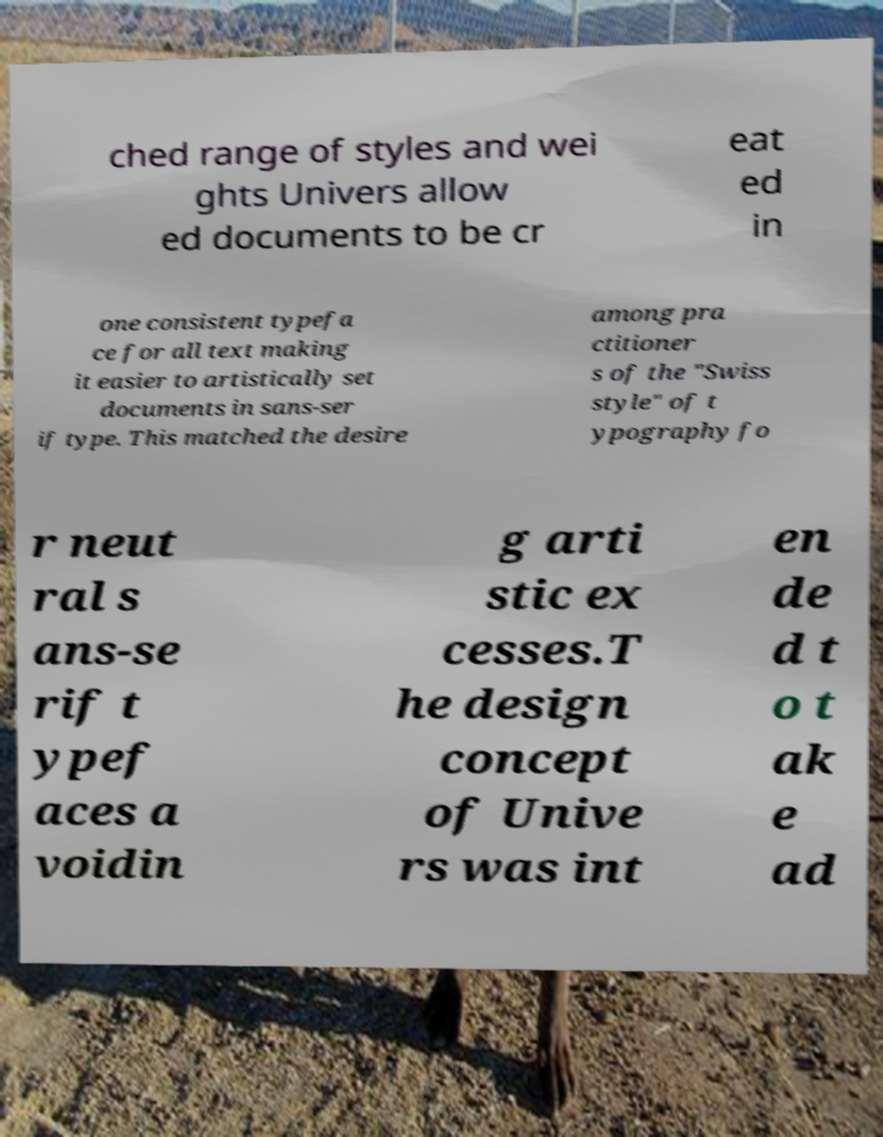Can you read and provide the text displayed in the image?This photo seems to have some interesting text. Can you extract and type it out for me? ched range of styles and wei ghts Univers allow ed documents to be cr eat ed in one consistent typefa ce for all text making it easier to artistically set documents in sans-ser if type. This matched the desire among pra ctitioner s of the "Swiss style" of t ypography fo r neut ral s ans-se rif t ypef aces a voidin g arti stic ex cesses.T he design concept of Unive rs was int en de d t o t ak e ad 